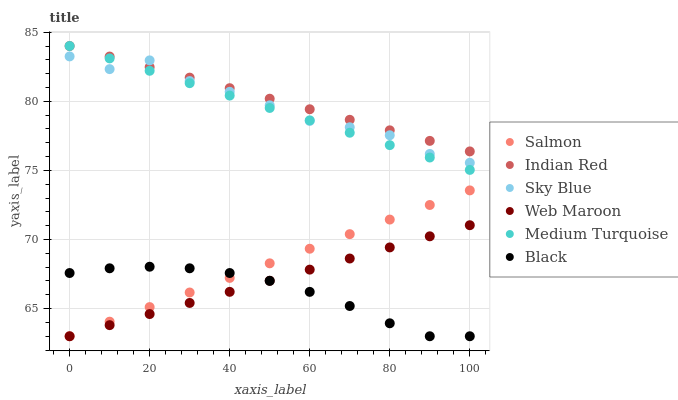Does Black have the minimum area under the curve?
Answer yes or no. Yes. Does Indian Red have the maximum area under the curve?
Answer yes or no. Yes. Does Salmon have the minimum area under the curve?
Answer yes or no. No. Does Salmon have the maximum area under the curve?
Answer yes or no. No. Is Indian Red the smoothest?
Answer yes or no. Yes. Is Sky Blue the roughest?
Answer yes or no. Yes. Is Web Maroon the smoothest?
Answer yes or no. No. Is Web Maroon the roughest?
Answer yes or no. No. Does Salmon have the lowest value?
Answer yes or no. Yes. Does Medium Turquoise have the lowest value?
Answer yes or no. No. Does Medium Turquoise have the highest value?
Answer yes or no. Yes. Does Salmon have the highest value?
Answer yes or no. No. Is Web Maroon less than Sky Blue?
Answer yes or no. Yes. Is Indian Red greater than Salmon?
Answer yes or no. Yes. Does Black intersect Web Maroon?
Answer yes or no. Yes. Is Black less than Web Maroon?
Answer yes or no. No. Is Black greater than Web Maroon?
Answer yes or no. No. Does Web Maroon intersect Sky Blue?
Answer yes or no. No. 